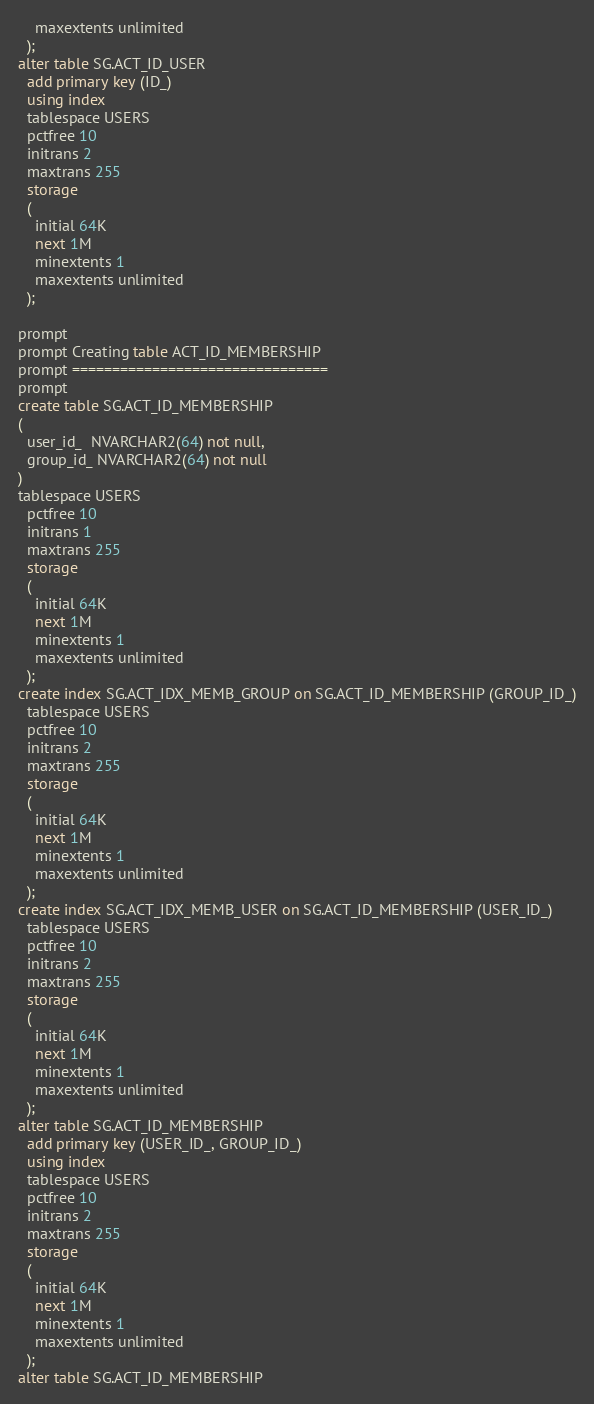<code> <loc_0><loc_0><loc_500><loc_500><_SQL_>    maxextents unlimited
  );
alter table SG.ACT_ID_USER
  add primary key (ID_)
  using index 
  tablespace USERS
  pctfree 10
  initrans 2
  maxtrans 255
  storage
  (
    initial 64K
    next 1M
    minextents 1
    maxextents unlimited
  );

prompt
prompt Creating table ACT_ID_MEMBERSHIP
prompt ================================
prompt
create table SG.ACT_ID_MEMBERSHIP
(
  user_id_  NVARCHAR2(64) not null,
  group_id_ NVARCHAR2(64) not null
)
tablespace USERS
  pctfree 10
  initrans 1
  maxtrans 255
  storage
  (
    initial 64K
    next 1M
    minextents 1
    maxextents unlimited
  );
create index SG.ACT_IDX_MEMB_GROUP on SG.ACT_ID_MEMBERSHIP (GROUP_ID_)
  tablespace USERS
  pctfree 10
  initrans 2
  maxtrans 255
  storage
  (
    initial 64K
    next 1M
    minextents 1
    maxextents unlimited
  );
create index SG.ACT_IDX_MEMB_USER on SG.ACT_ID_MEMBERSHIP (USER_ID_)
  tablespace USERS
  pctfree 10
  initrans 2
  maxtrans 255
  storage
  (
    initial 64K
    next 1M
    minextents 1
    maxextents unlimited
  );
alter table SG.ACT_ID_MEMBERSHIP
  add primary key (USER_ID_, GROUP_ID_)
  using index 
  tablespace USERS
  pctfree 10
  initrans 2
  maxtrans 255
  storage
  (
    initial 64K
    next 1M
    minextents 1
    maxextents unlimited
  );
alter table SG.ACT_ID_MEMBERSHIP</code> 